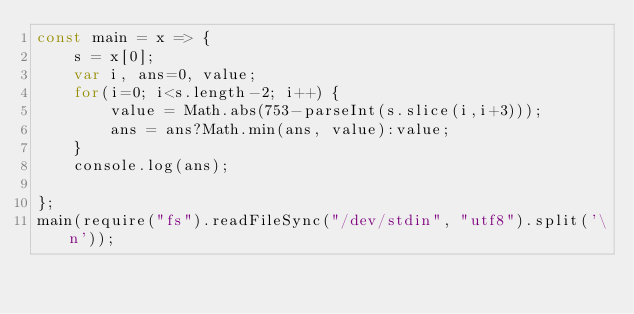Convert code to text. <code><loc_0><loc_0><loc_500><loc_500><_JavaScript_>const main = x => {
    s = x[0];
    var i, ans=0, value;
    for(i=0; i<s.length-2; i++) {
        value = Math.abs(753-parseInt(s.slice(i,i+3)));
        ans = ans?Math.min(ans, value):value;
    }
    console.log(ans);
    
};
main(require("fs").readFileSync("/dev/stdin", "utf8").split('\n'));</code> 